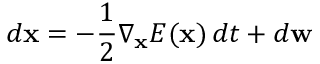Convert formula to latex. <formula><loc_0><loc_0><loc_500><loc_500>d x = - \frac { 1 } { 2 } \nabla _ { x } E ( x ) \, d t + d w</formula> 